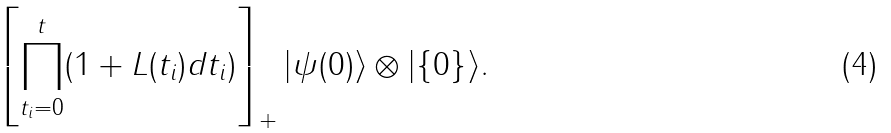<formula> <loc_0><loc_0><loc_500><loc_500>\left [ \prod _ { t _ { i } = 0 } ^ { t } ( 1 + L ( t _ { i } ) d t _ { i } ) \right ] _ { + } | \psi ( 0 ) \rangle \otimes | \{ 0 \} \rangle .</formula> 